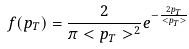Convert formula to latex. <formula><loc_0><loc_0><loc_500><loc_500>f ( p _ { T } ) = \frac { 2 } { \pi < p _ { T } > ^ { 2 } } e ^ { - \frac { 2 p _ { T } } { < p _ { T } > } }</formula> 